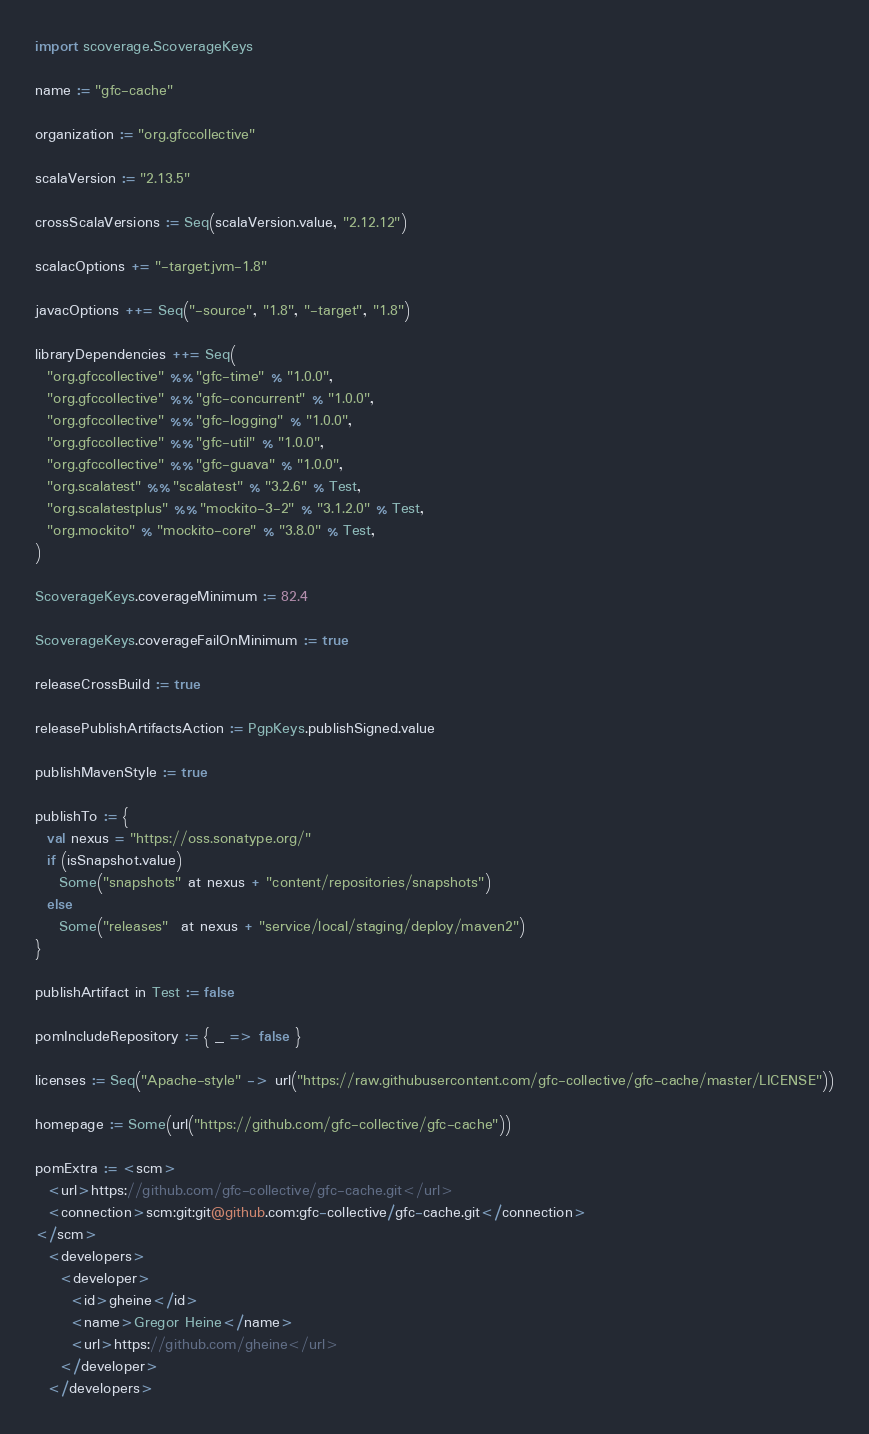Convert code to text. <code><loc_0><loc_0><loc_500><loc_500><_Scala_>import scoverage.ScoverageKeys

name := "gfc-cache"

organization := "org.gfccollective"

scalaVersion := "2.13.5"

crossScalaVersions := Seq(scalaVersion.value, "2.12.12")

scalacOptions += "-target:jvm-1.8"

javacOptions ++= Seq("-source", "1.8", "-target", "1.8")

libraryDependencies ++= Seq(
  "org.gfccollective" %% "gfc-time" % "1.0.0",
  "org.gfccollective" %% "gfc-concurrent" % "1.0.0",
  "org.gfccollective" %% "gfc-logging" % "1.0.0",
  "org.gfccollective" %% "gfc-util" % "1.0.0",
  "org.gfccollective" %% "gfc-guava" % "1.0.0",
  "org.scalatest" %% "scalatest" % "3.2.6" % Test,
  "org.scalatestplus" %% "mockito-3-2" % "3.1.2.0" % Test,
  "org.mockito" % "mockito-core" % "3.8.0" % Test,
)

ScoverageKeys.coverageMinimum := 82.4

ScoverageKeys.coverageFailOnMinimum := true

releaseCrossBuild := true

releasePublishArtifactsAction := PgpKeys.publishSigned.value

publishMavenStyle := true

publishTo := {
  val nexus = "https://oss.sonatype.org/"
  if (isSnapshot.value)
    Some("snapshots" at nexus + "content/repositories/snapshots")
  else
    Some("releases"  at nexus + "service/local/staging/deploy/maven2")
}

publishArtifact in Test := false

pomIncludeRepository := { _ => false }

licenses := Seq("Apache-style" -> url("https://raw.githubusercontent.com/gfc-collective/gfc-cache/master/LICENSE"))

homepage := Some(url("https://github.com/gfc-collective/gfc-cache"))

pomExtra := <scm>
  <url>https://github.com/gfc-collective/gfc-cache.git</url>
  <connection>scm:git:git@github.com:gfc-collective/gfc-cache.git</connection>
</scm>
  <developers>
    <developer>
      <id>gheine</id>
      <name>Gregor Heine</name>
      <url>https://github.com/gheine</url>
    </developer>
  </developers>
</code> 